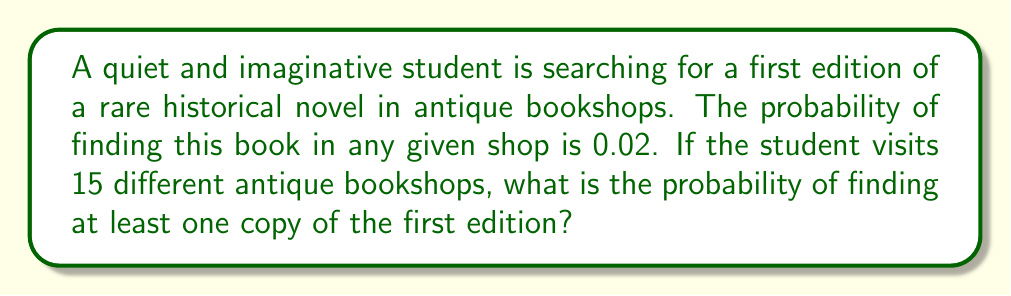Can you solve this math problem? To solve this problem, we can use the concept of complementary events. Instead of calculating the probability of finding at least one copy, we can calculate the probability of not finding any copies and then subtract that from 1.

Let's approach this step-by-step:

1) The probability of not finding the book in a single shop is:
   $1 - 0.02 = 0.98$

2) For 15 independent visits, the probability of not finding the book in any of them is:
   $(0.98)^{15}$

3) Therefore, the probability of finding at least one copy is:
   $1 - (0.98)^{15}$

4) Let's calculate this:
   $$\begin{align}
   P(\text{at least one}) &= 1 - (0.98)^{15} \\
   &= 1 - 0.7386 \\
   &= 0.2614
   \end{align}$$

5) We can express this as a percentage:
   $0.2614 \times 100\% = 26.14\%$

This means that the quiet and imaginative student has approximately a 26.14% chance of finding at least one copy of the first edition of the rare historical novel after visiting 15 antique bookshops.
Answer: The probability of finding at least one copy of the first edition in 15 antique bookshops is approximately 0.2614 or 26.14%. 